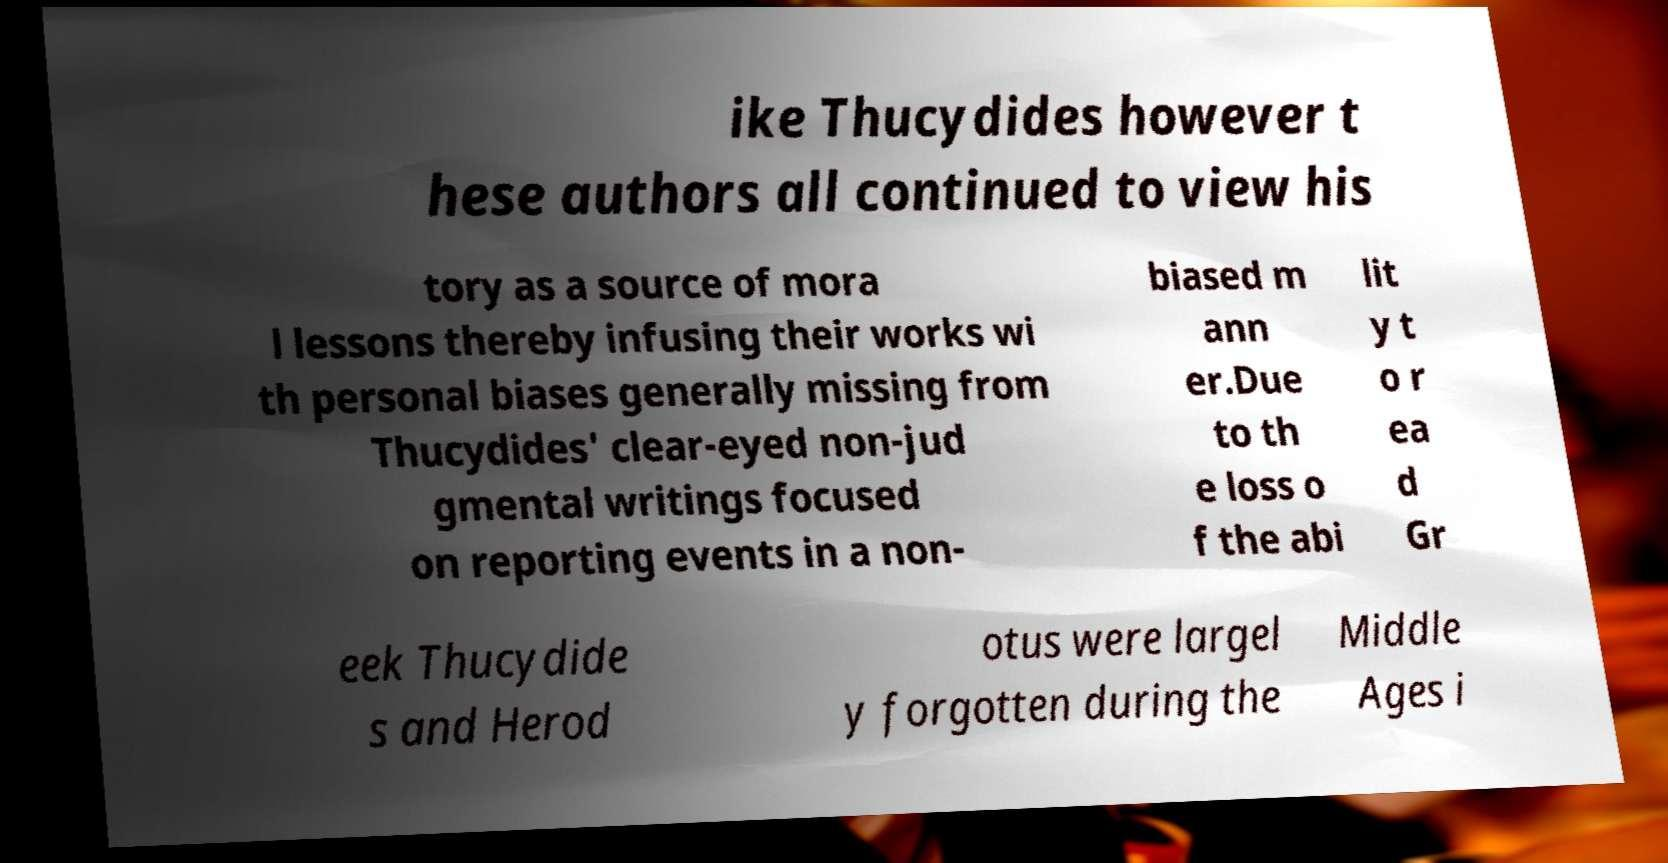Please identify and transcribe the text found in this image. ike Thucydides however t hese authors all continued to view his tory as a source of mora l lessons thereby infusing their works wi th personal biases generally missing from Thucydides' clear-eyed non-jud gmental writings focused on reporting events in a non- biased m ann er.Due to th e loss o f the abi lit y t o r ea d Gr eek Thucydide s and Herod otus were largel y forgotten during the Middle Ages i 